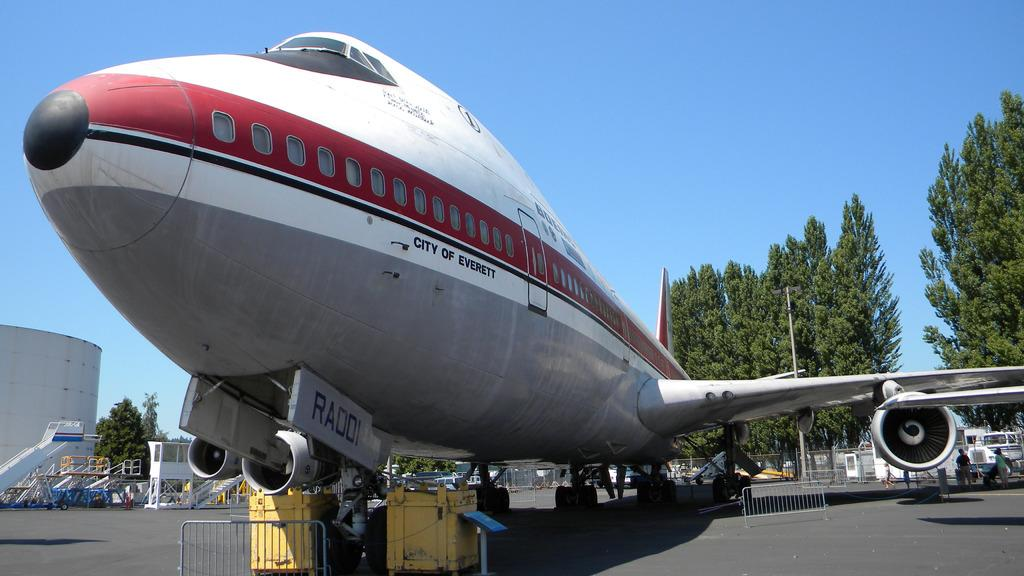<image>
Offer a succinct explanation of the picture presented. A front shot of an airplane for the City of Everett 